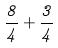<formula> <loc_0><loc_0><loc_500><loc_500>\frac { 8 } { 4 } + \frac { 3 } { 4 }</formula> 